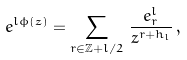<formula> <loc_0><loc_0><loc_500><loc_500>\ e ^ { l \phi ( z ) } = \sum _ { r \in \mathbb { Z } + l / 2 } \, \frac { e ^ { l } _ { r } } { z ^ { r + h _ { l } } } \, ,</formula> 